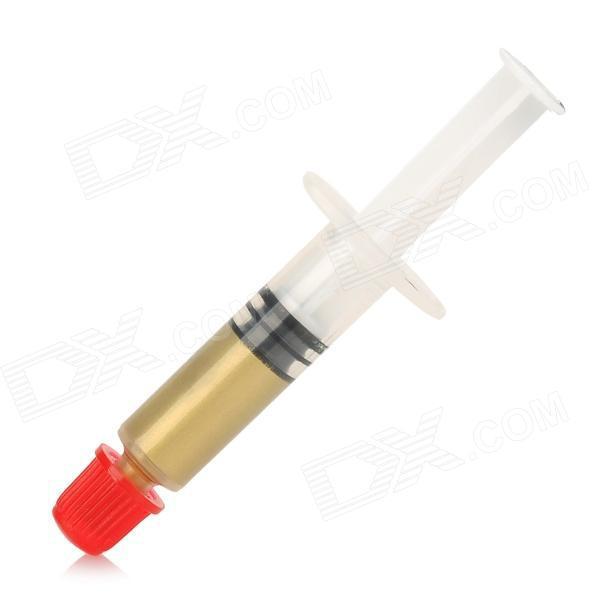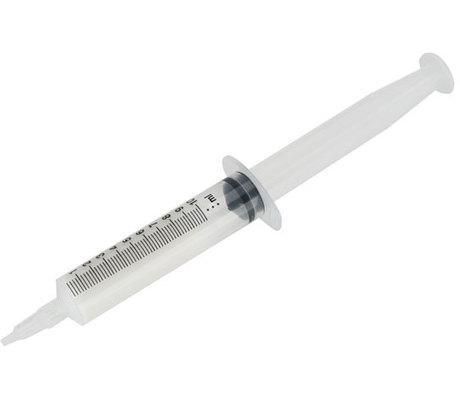The first image is the image on the left, the second image is the image on the right. Examine the images to the left and right. Is the description "One is pointing up to the right, and the other down to the left." accurate? Answer yes or no. No. The first image is the image on the left, the second image is the image on the right. Assess this claim about the two images: "there at least one syringe in the image on the left". Correct or not? Answer yes or no. Yes. 